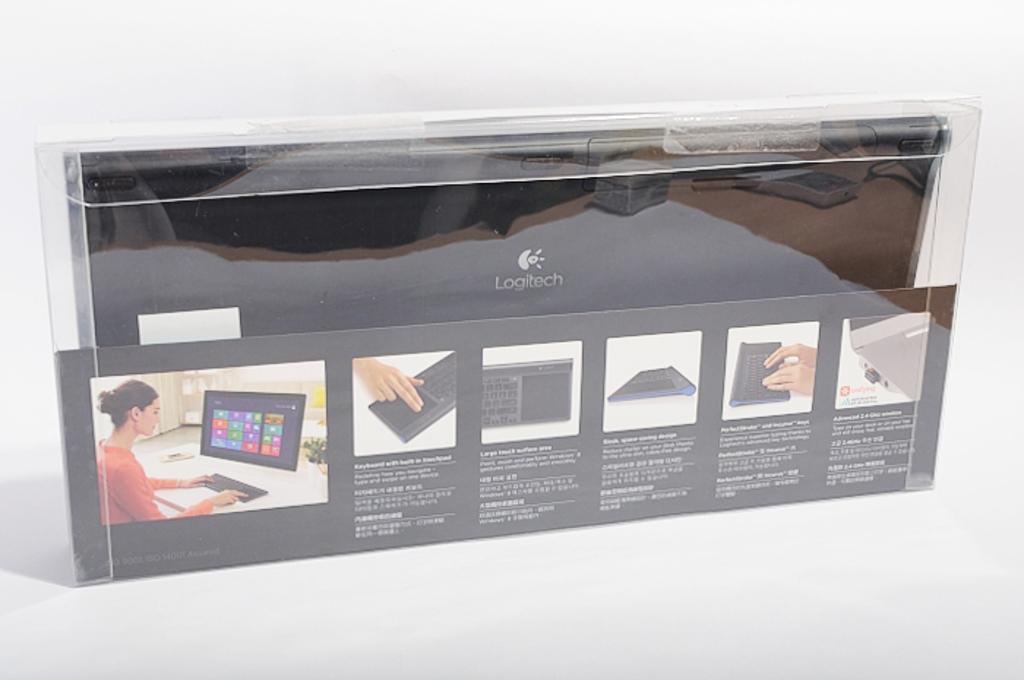What brand of technology is this?
Your answer should be very brief. Logitech. 